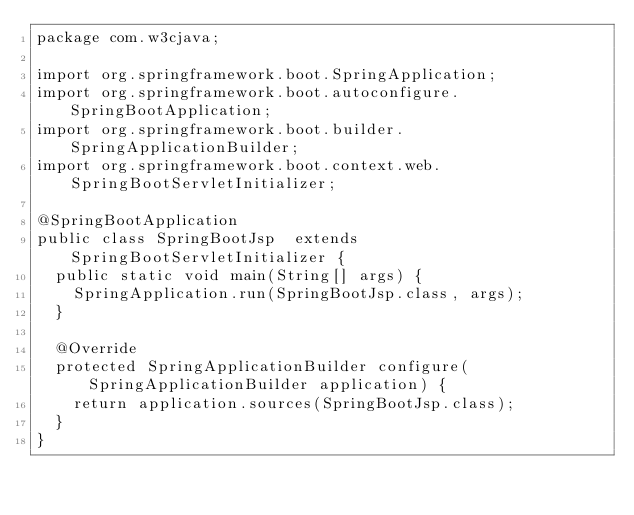Convert code to text. <code><loc_0><loc_0><loc_500><loc_500><_Java_>package com.w3cjava;

import org.springframework.boot.SpringApplication;
import org.springframework.boot.autoconfigure.SpringBootApplication;
import org.springframework.boot.builder.SpringApplicationBuilder;
import org.springframework.boot.context.web.SpringBootServletInitializer;

@SpringBootApplication
public class SpringBootJsp  extends SpringBootServletInitializer {
	public static void main(String[] args) {
		SpringApplication.run(SpringBootJsp.class, args);
	}
	
	@Override
	protected SpringApplicationBuilder configure(SpringApplicationBuilder application) {
		return application.sources(SpringBootJsp.class);
	}
}
</code> 